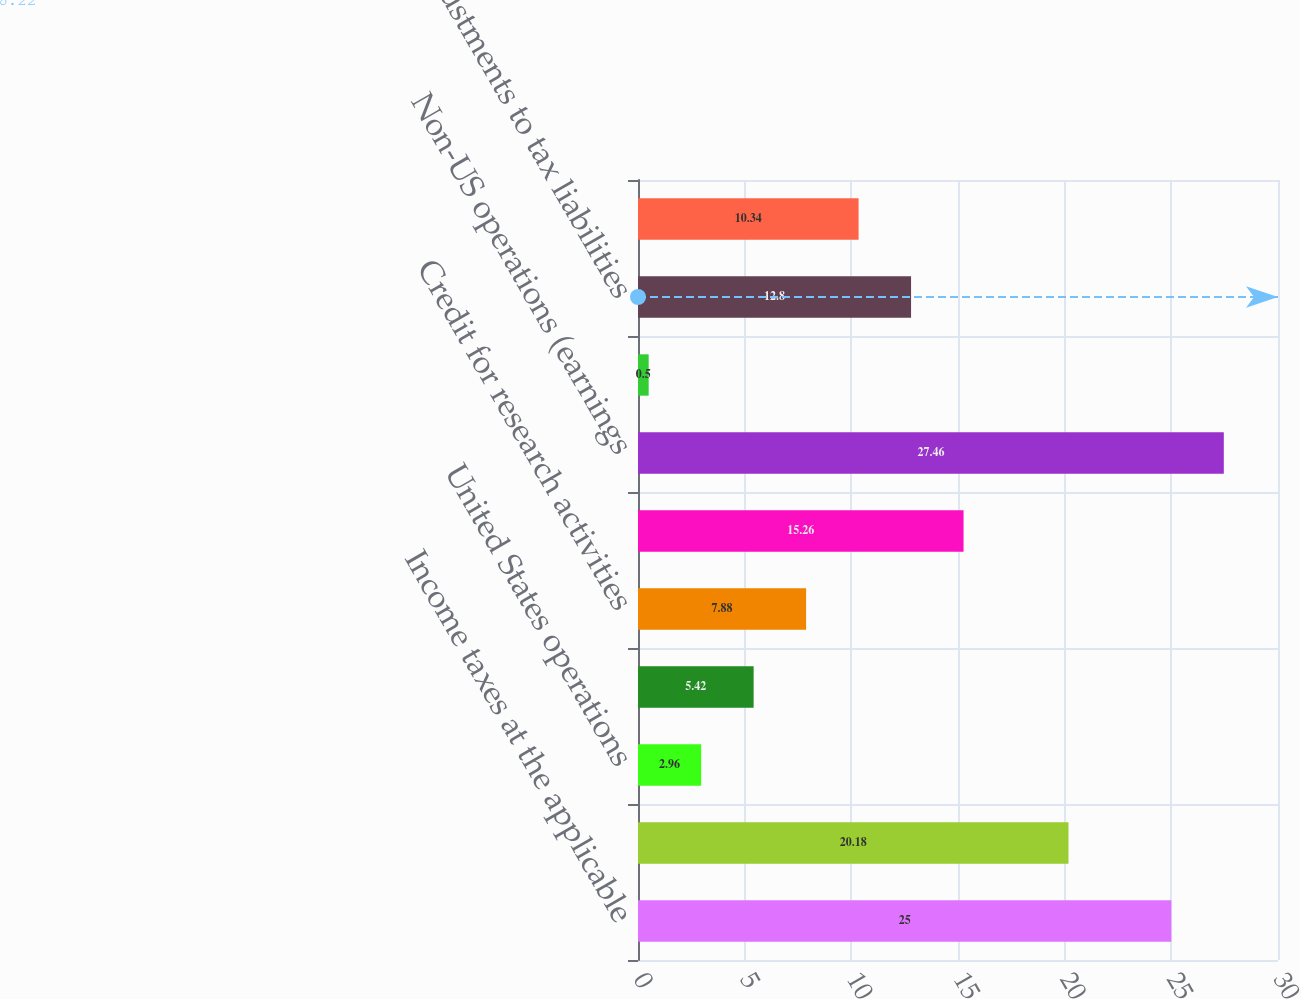Convert chart to OTSL. <chart><loc_0><loc_0><loc_500><loc_500><bar_chart><fcel>Income taxes at the applicable<fcel>Nondeductible interest expense<fcel>United States operations<fcel>US foreign tax credit<fcel>Credit for research activities<fcel>US Other - net<fcel>Non-US operations (earnings<fcel>Non-US operations - other<fcel>Adjustments to tax liabilities<fcel>Adjustments to valuation<nl><fcel>25<fcel>20.18<fcel>2.96<fcel>5.42<fcel>7.88<fcel>15.26<fcel>27.46<fcel>0.5<fcel>12.8<fcel>10.34<nl></chart> 